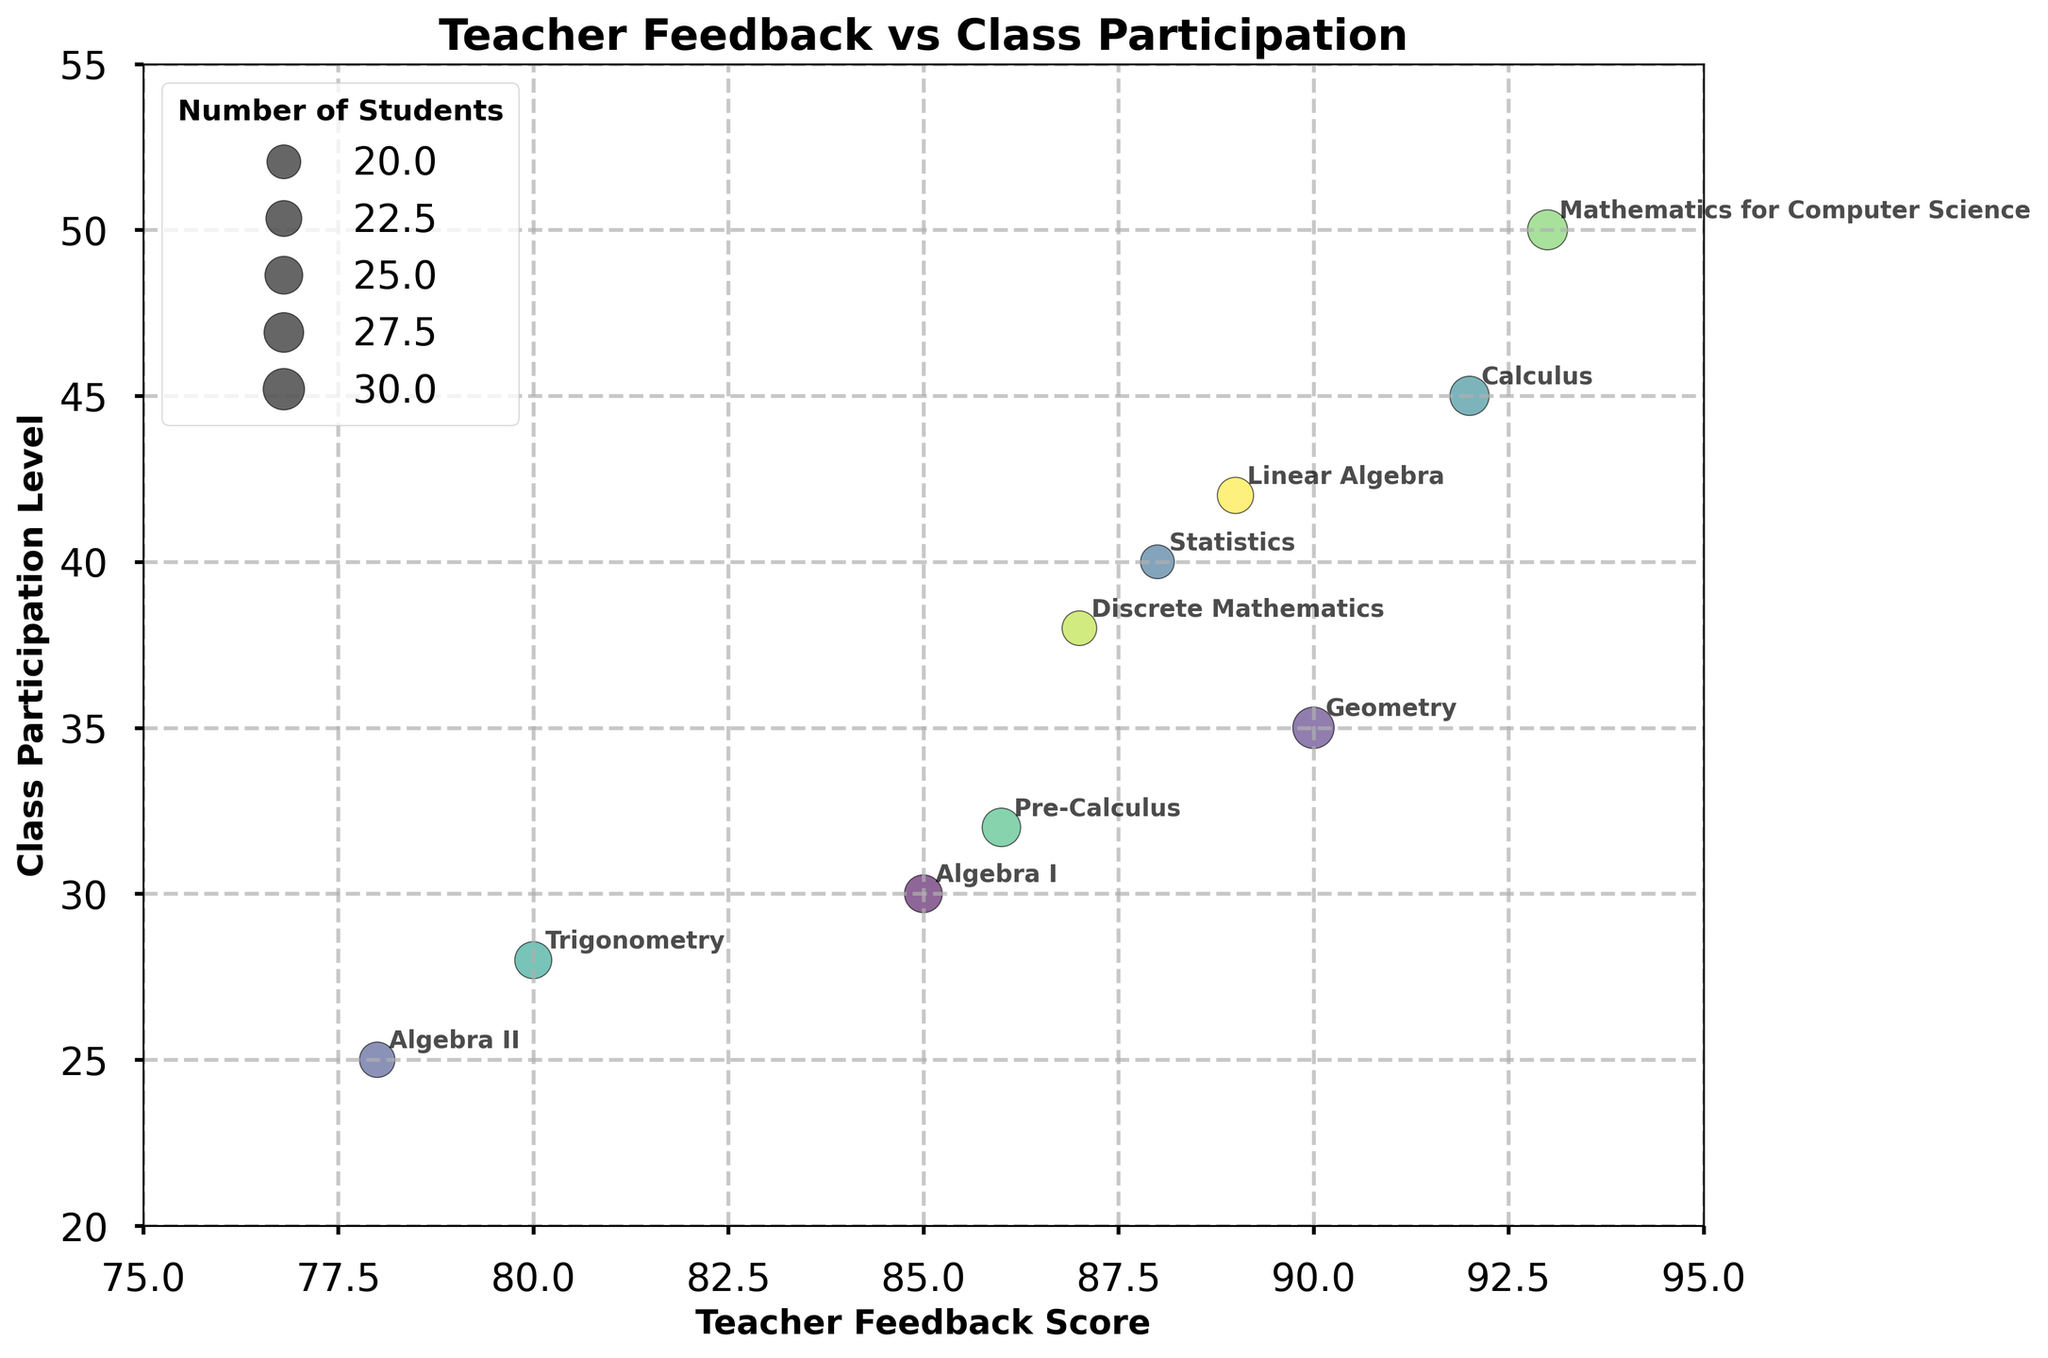What's the title of the figure? The title of the figure is displayed prominently at the top and provides an overview of what the figure represents. The title here is "Teacher Feedback vs Class Participation".
Answer: Teacher Feedback vs Class Participation Which class has the highest class participation level? To determine the class with the highest participation level, look at the y-axis and find the highest point on the chart. The class labeled "Mathematics for Computer Science" is at the top of the y-axis with a participation level of 50.
Answer: Mathematics for Computer Science How many class bubbles are plotted in the figure? Count the number of bubbles plotted on the figure, each representing a class. There are 10 distinct bubbles, each labeled with a class name.
Answer: 10 Which teacher's class has the lowest teacher feedback score, and what is the value? Look at the x-axis and identify the lowest value for teacher feedback score. The "Algebra II" class taught by Mark Johnson has the lowest score, which is 78.
Answer: Algebra II, 78 Compare the teacher feedback score of "Geometry" and "Trigonometry". Which one is higher and by how much? The teacher feedback score for "Geometry" is 90, and for "Trigonometry" it is 80. To find the difference, subtract the lower score from the higher one: 90 - 80 = 10. Therefore, "Geometry" has a higher score by 10 points.
Answer: Geometry, by 10 points Which class has a teacher feedback score of 92? Locate the bubble on the x-axis with a feedback score of 92. The class labeled "Calculus" has the teacher feedback score of 92.
Answer: Calculus Are there more classes with participation levels above 30 or below 30? Count the number of bubbles above the y-value of 30 and the number below. There are 7 classes with participation levels above 30 and 3 classes below 30.
Answer: Above 30 What's the average class participation level for the classes with teacher feedback scores above 85? Identify classes with feedback scores above 85: Algebra I (30), Geometry (35), Statistics (40), Calculus (45), Pre-Calculus (32), Mathematics for Computer Science (50), Discrete Mathematics (38), Linear Algebra (42). Calculate the sum of their participation levels: 30 + 35 + 40 + 45 + 32 + 50 + 38 + 42 = 312. Dividing this sum by the number of classes (8) gives an average participation level of 312 / 8 = 39.
Answer: 39 Which class has the largest number of students and what is the class participation level for that class? Find the bubble with the largest size (diameter), which indicates the class with the most students. "Mathematics for Computer Science" has the largest bubble; it has 28 students and a participation level of 50.
Answer: Mathematics for Computer Science, 50 Is there a general trend between teacher feedback scores and class participation levels? Observing the scatter plot, a positive trend is apparent where higher teacher feedback scores tend to correlate with higher class participation levels. The majority of classes with higher feedback scores also show higher levels of participation.
Answer: Yes, positive trend 